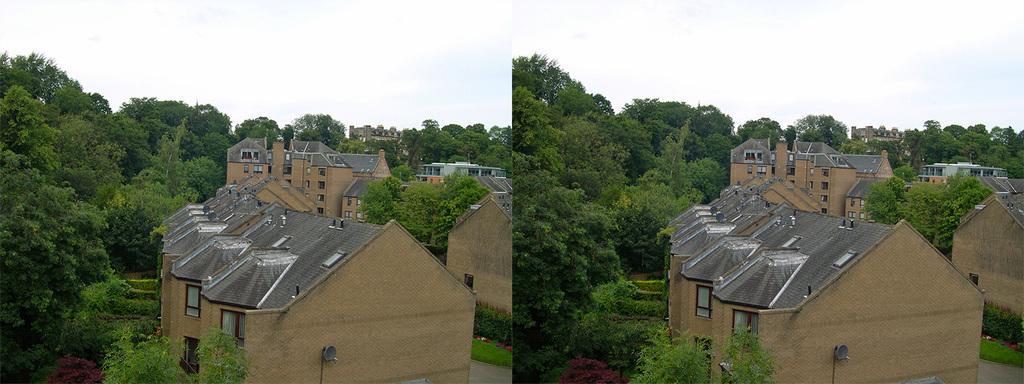Could you give a brief overview of what you see in this image? As we can see in the image, on the top there is a clear sky and there are lot of trees and buildings. The rooftop of the houses is in brown color. 